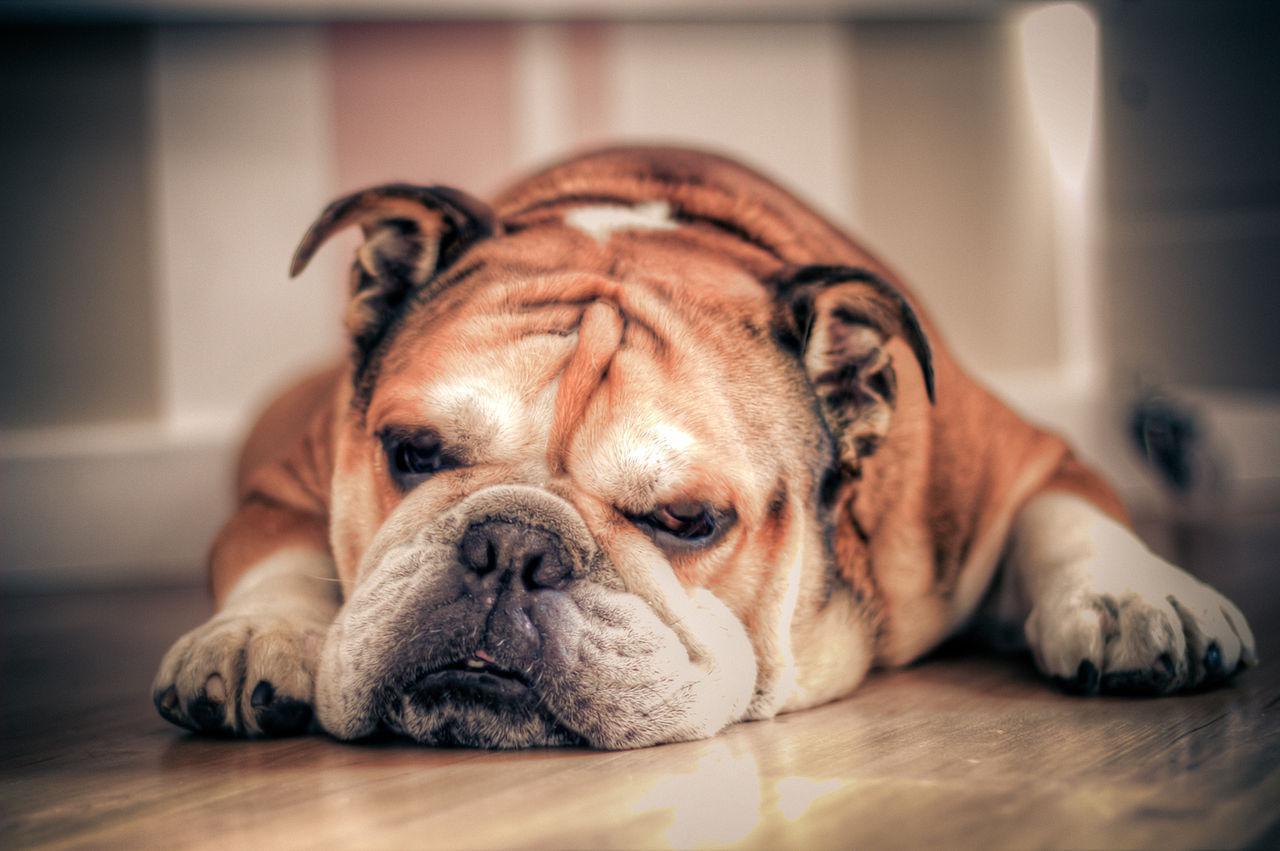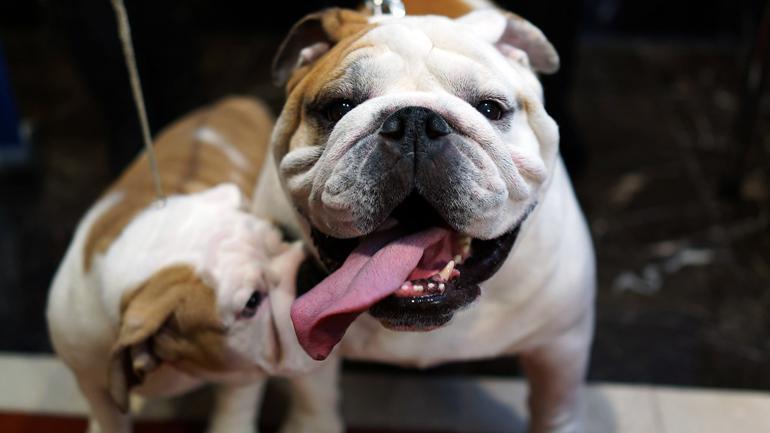The first image is the image on the left, the second image is the image on the right. Considering the images on both sides, is "There are two dogs in the right image." valid? Answer yes or no. Yes. The first image is the image on the left, the second image is the image on the right. For the images shown, is this caption "The right image shows two dogs, while the left image shows just one" true? Answer yes or no. Yes. 